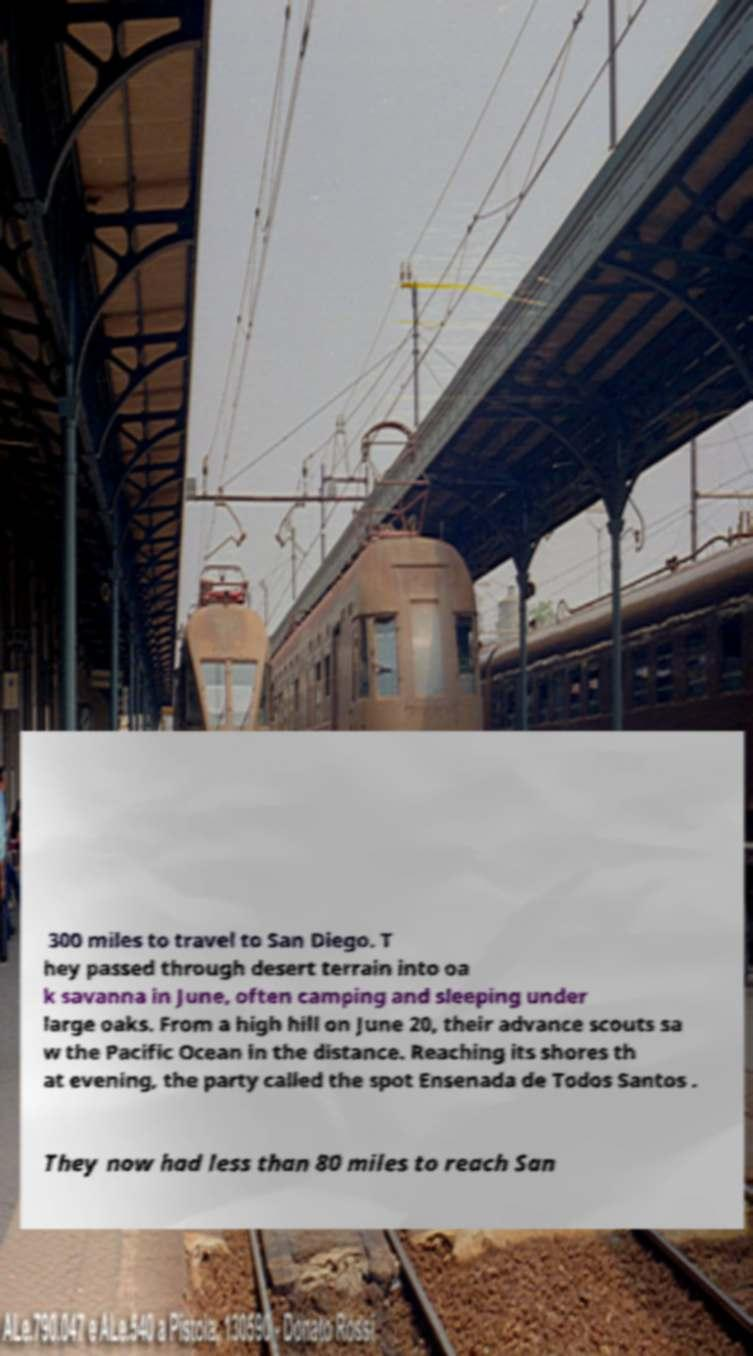For documentation purposes, I need the text within this image transcribed. Could you provide that? 300 miles to travel to San Diego. T hey passed through desert terrain into oa k savanna in June, often camping and sleeping under large oaks. From a high hill on June 20, their advance scouts sa w the Pacific Ocean in the distance. Reaching its shores th at evening, the party called the spot Ensenada de Todos Santos . They now had less than 80 miles to reach San 